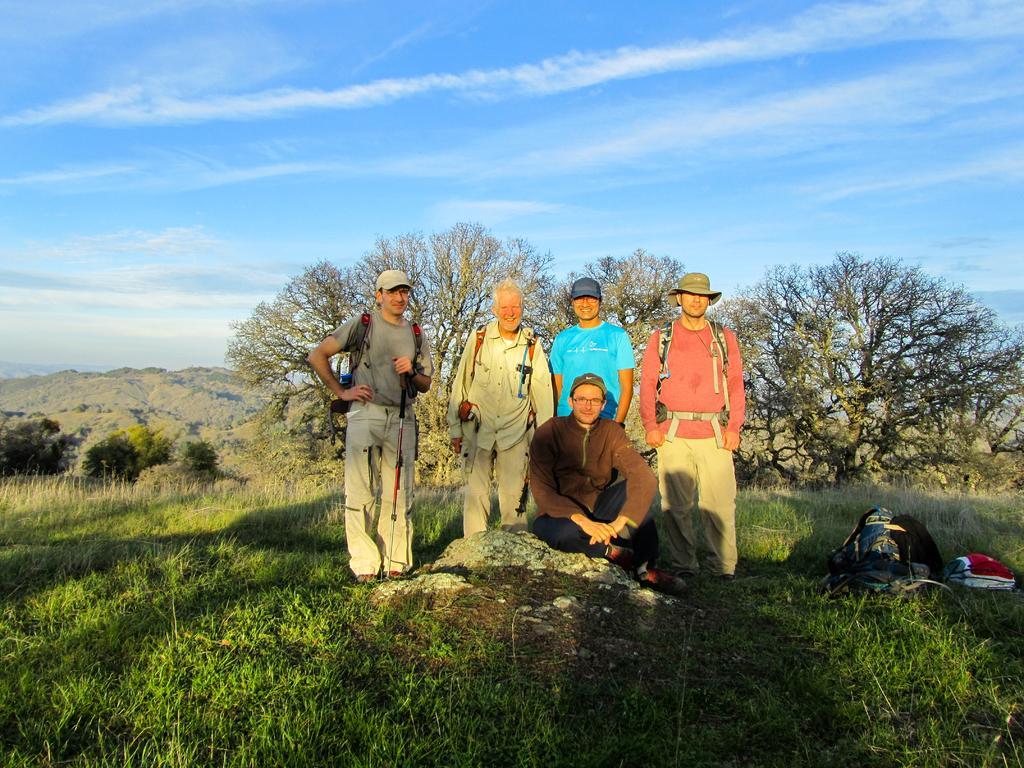How would you summarize this image in a sentence or two? In this image, we can see people. Few people are smiling and watching. Here a person is sitting on a stone. At the bottom, we can see grass and backpacks. Background we can see trees, hill and sky. 